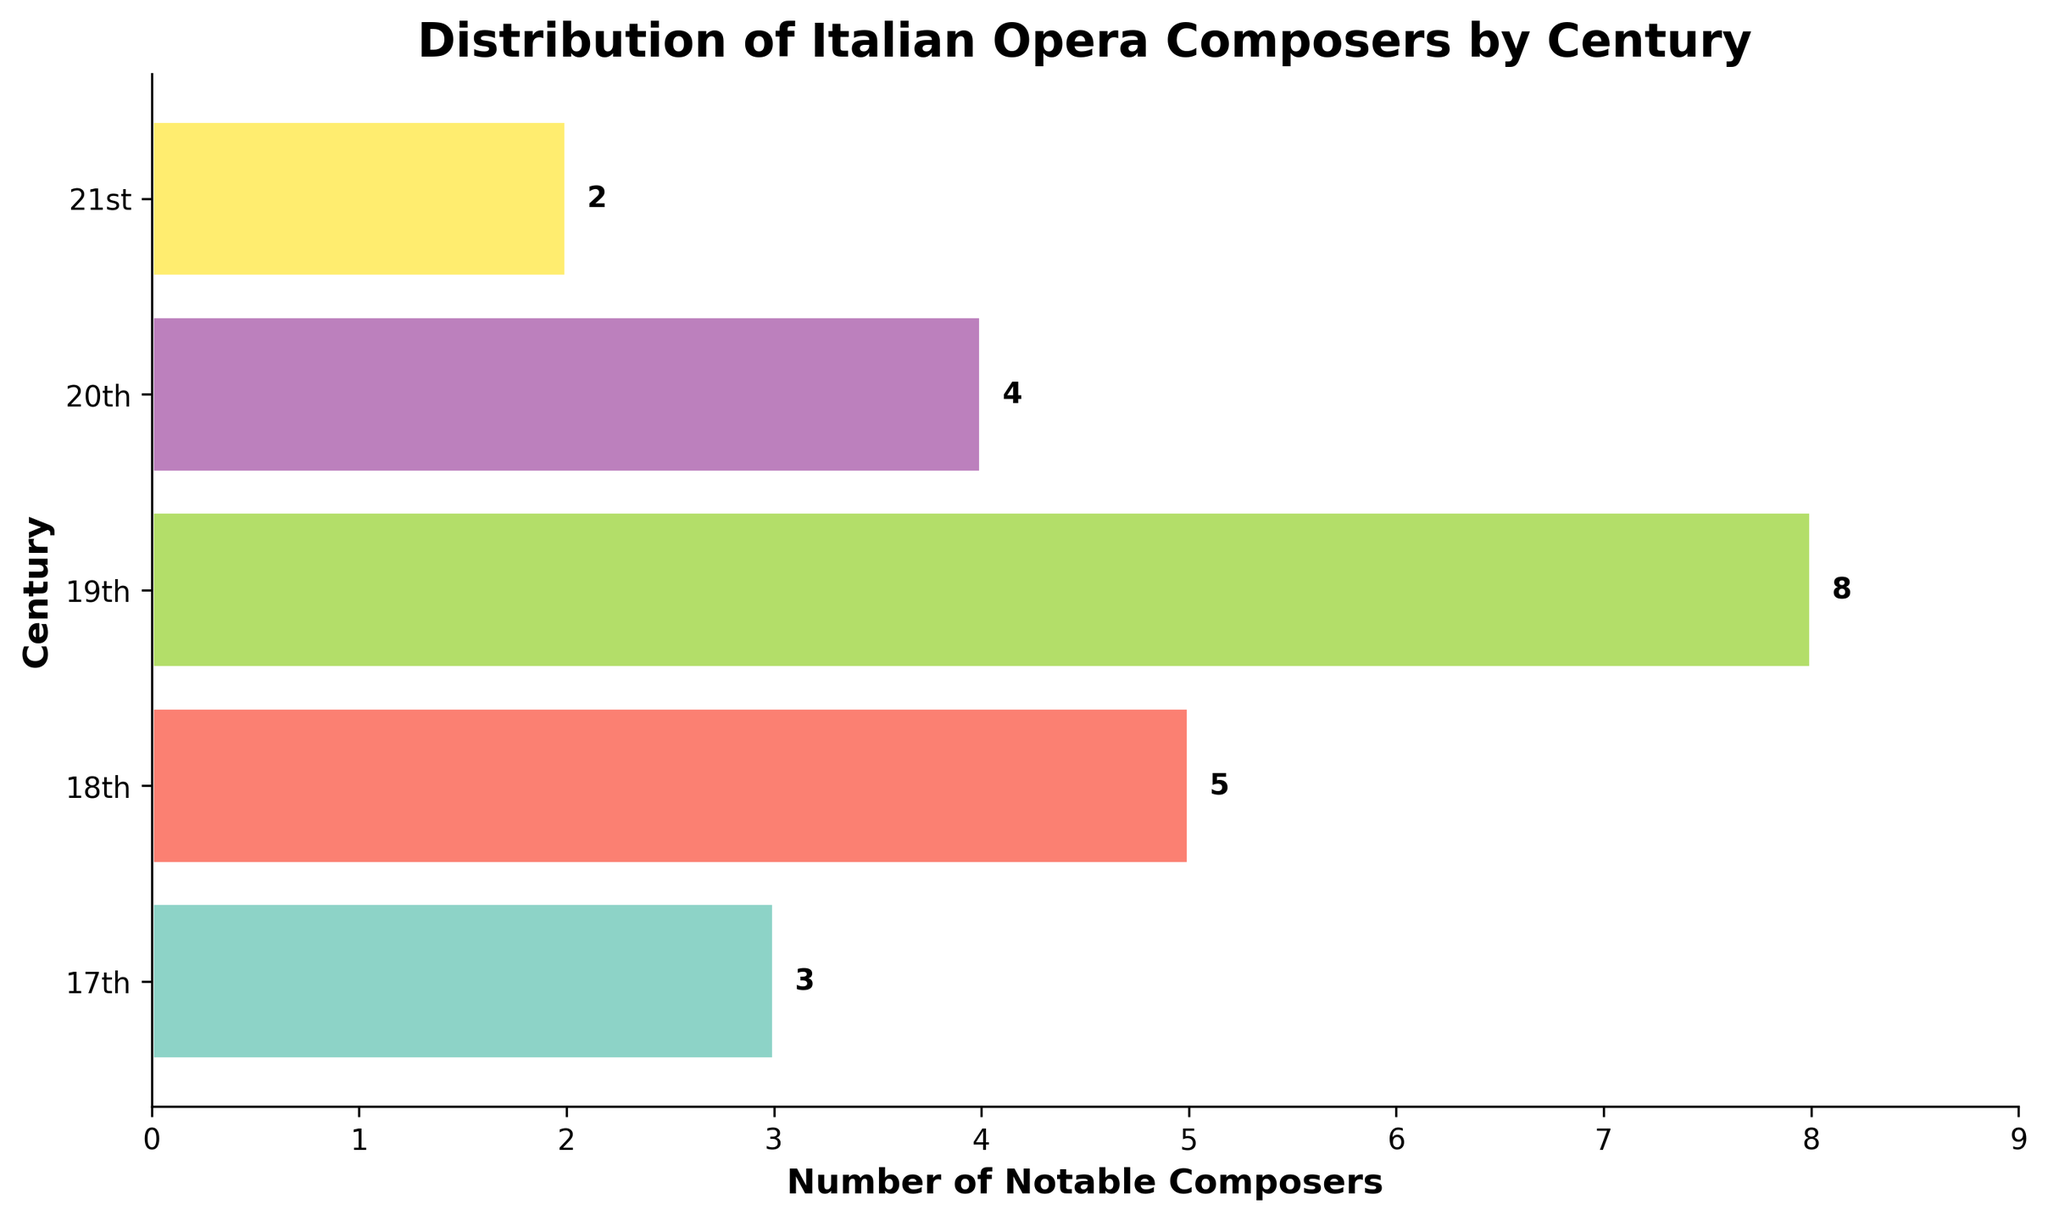What century has the highest number of notable Italian opera composers? The bar representing the 19th century is the longest, indicating it has the highest number of notable composers.
Answer: 19th How many more notable composers are there in the 19th century compared to the 20th century? The 19th century has 8 notable composers, while the 20th century has 4. Subtracting gives 8 - 4 = 4.
Answer: 4 What is the total number of notable Italian opera composers across all centuries depicted in the figure? Add the values of all bars: 3 (17th) + 5 (18th) + 8 (19th) + 4 (20th) + 2 (21st) = 22.
Answer: 22 Which century has the least number of notable Italian opera composers, and what is the number? The bar representing the 21st century is the shortest, indicating it has the least number of notable composers, which is 2.
Answer: 21st, 2 What is the difference in the number of notable composers between the 18th and 17th centuries? The 18th century has 5 notable composers and the 17th century has 3. Subtracting gives 5 - 3 = 2.
Answer: 2 What is the average number of notable composers per century? The total number of composers is 22. There are 5 centuries. Dividing gives 22 / 5 = 4.4.
Answer: 4.4 Which two consecutive centuries saw the largest increase in the number of notable Italian opera composers? The increases are: 18th to 19th (8 - 5 = 3), 17th to 18th (5 - 3 = 2), 19th to 20th (4 - 8 = -4), and 20th to 21st (2 - 4 = -2). The largest increase is from the 17th to the 18th century: 2.
Answer: 17th to 18th How does the 19th-century number of composers compare to the average number of composers? The 19th century has 8 composers. The average is 4.4. Since 8 is greater than 4.4, there are more composers in the 19th century than average.
Answer: More What is the combined total of notable composers in the 20th and 21st centuries? The numbers are 4 (20th) and 2 (21st). Adding gives 4 + 2 = 6.
Answer: 6 Which century has a number of composers that is exactly double that of another century, and which centuries are they? The 18th century has 5 composers and the 17th century has 3. None of these numbers is double the other. The 19th century has 8, which is not double of 3, 5, 2, or 4. Thus, no century has double the composers of another century.
Answer: None 